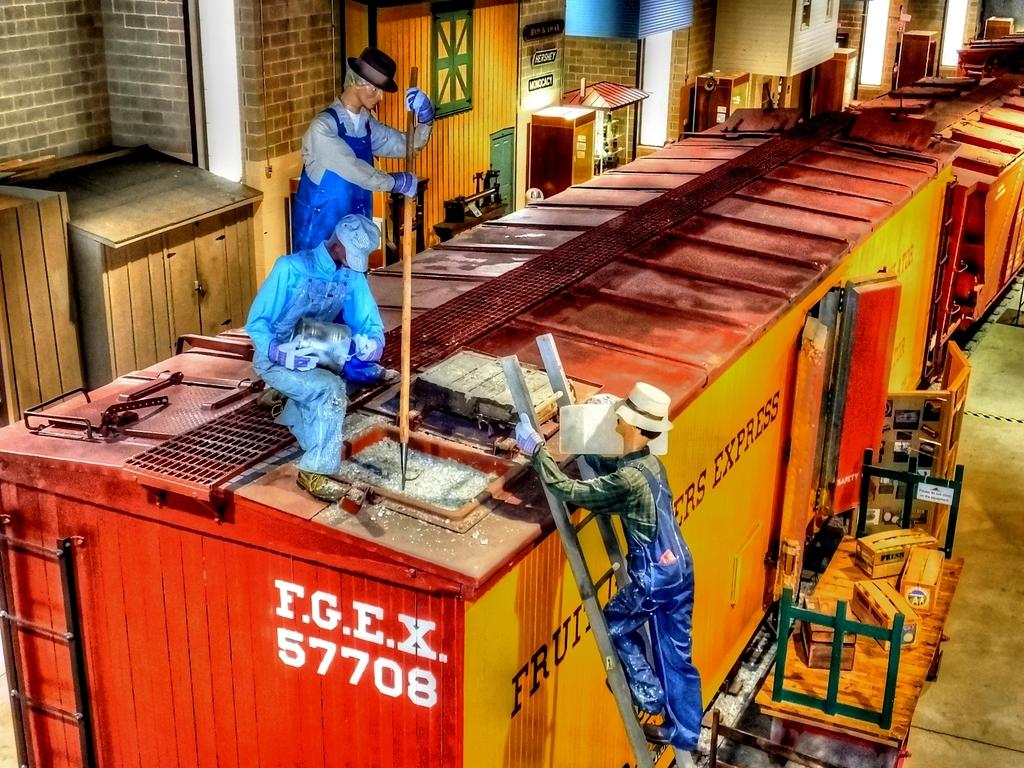What type of vehicles can be seen in the image? There are trucks in the image. What type of furniture is present in the image? There are cupboards in the image. What type of illumination is visible in the image? There are lights in the image. What type of decorative objects can be seen in the image? There are statues in the image. What type of structure is present in the image? There is a wall in the image. What type of kettle is used to create pleasure in the image? There is no kettle present in the image, and the concept of pleasure is not relevant to the image. What type of soap is used to clean the statues in the image? There is no soap present in the image, and the statues do not require cleaning. 